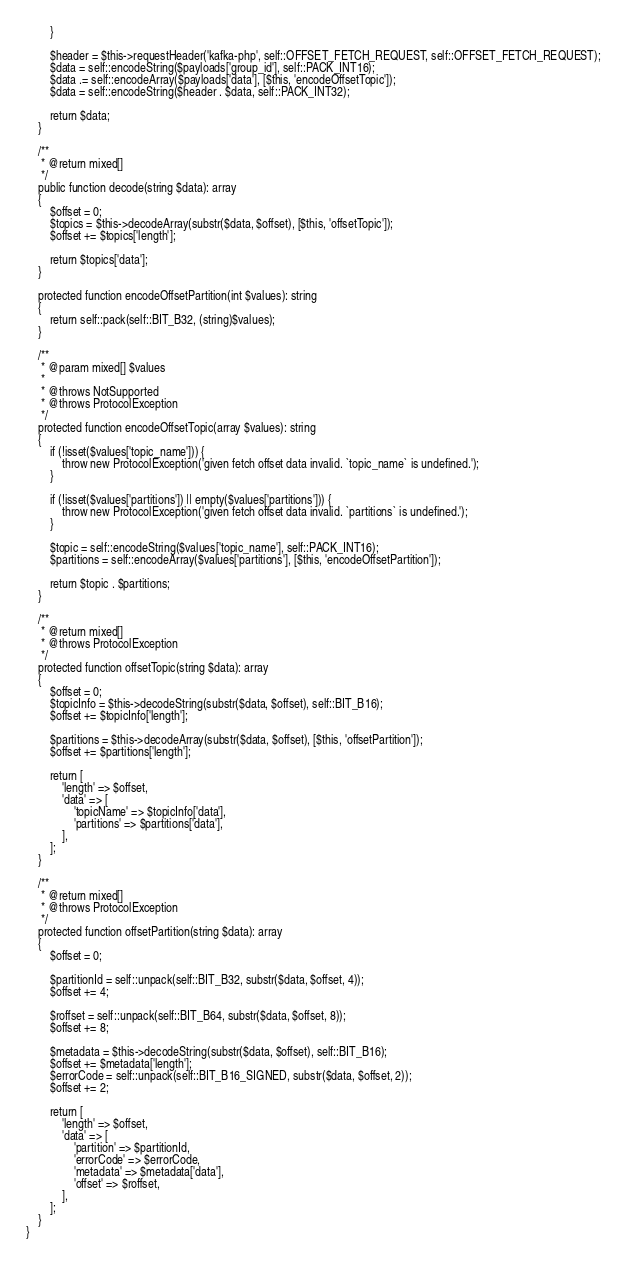Convert code to text. <code><loc_0><loc_0><loc_500><loc_500><_PHP_>        }

        $header = $this->requestHeader('kafka-php', self::OFFSET_FETCH_REQUEST, self::OFFSET_FETCH_REQUEST);
        $data = self::encodeString($payloads['group_id'], self::PACK_INT16);
        $data .= self::encodeArray($payloads['data'], [$this, 'encodeOffsetTopic']);
        $data = self::encodeString($header . $data, self::PACK_INT32);

        return $data;
    }

    /**
     * @return mixed[]
     */
    public function decode(string $data): array
    {
        $offset = 0;
        $topics = $this->decodeArray(substr($data, $offset), [$this, 'offsetTopic']);
        $offset += $topics['length'];

        return $topics['data'];
    }

    protected function encodeOffsetPartition(int $values): string
    {
        return self::pack(self::BIT_B32, (string)$values);
    }

    /**
     * @param mixed[] $values
     *
     * @throws NotSupported
     * @throws ProtocolException
     */
    protected function encodeOffsetTopic(array $values): string
    {
        if (!isset($values['topic_name'])) {
            throw new ProtocolException('given fetch offset data invalid. `topic_name` is undefined.');
        }

        if (!isset($values['partitions']) || empty($values['partitions'])) {
            throw new ProtocolException('given fetch offset data invalid. `partitions` is undefined.');
        }

        $topic = self::encodeString($values['topic_name'], self::PACK_INT16);
        $partitions = self::encodeArray($values['partitions'], [$this, 'encodeOffsetPartition']);

        return $topic . $partitions;
    }

    /**
     * @return mixed[]
     * @throws ProtocolException
     */
    protected function offsetTopic(string $data): array
    {
        $offset = 0;
        $topicInfo = $this->decodeString(substr($data, $offset), self::BIT_B16);
        $offset += $topicInfo['length'];

        $partitions = $this->decodeArray(substr($data, $offset), [$this, 'offsetPartition']);
        $offset += $partitions['length'];

        return [
            'length' => $offset,
            'data' => [
                'topicName' => $topicInfo['data'],
                'partitions' => $partitions['data'],
            ],
        ];
    }

    /**
     * @return mixed[]
     * @throws ProtocolException
     */
    protected function offsetPartition(string $data): array
    {
        $offset = 0;

        $partitionId = self::unpack(self::BIT_B32, substr($data, $offset, 4));
        $offset += 4;

        $roffset = self::unpack(self::BIT_B64, substr($data, $offset, 8));
        $offset += 8;

        $metadata = $this->decodeString(substr($data, $offset), self::BIT_B16);
        $offset += $metadata['length'];
        $errorCode = self::unpack(self::BIT_B16_SIGNED, substr($data, $offset, 2));
        $offset += 2;

        return [
            'length' => $offset,
            'data' => [
                'partition' => $partitionId,
                'errorCode' => $errorCode,
                'metadata' => $metadata['data'],
                'offset' => $roffset,
            ],
        ];
    }
}
</code> 